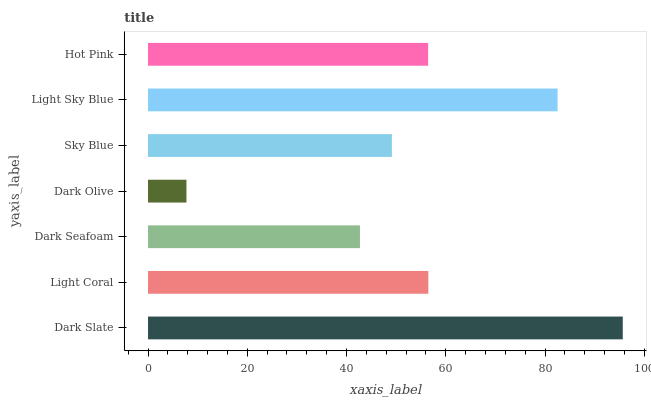Is Dark Olive the minimum?
Answer yes or no. Yes. Is Dark Slate the maximum?
Answer yes or no. Yes. Is Light Coral the minimum?
Answer yes or no. No. Is Light Coral the maximum?
Answer yes or no. No. Is Dark Slate greater than Light Coral?
Answer yes or no. Yes. Is Light Coral less than Dark Slate?
Answer yes or no. Yes. Is Light Coral greater than Dark Slate?
Answer yes or no. No. Is Dark Slate less than Light Coral?
Answer yes or no. No. Is Hot Pink the high median?
Answer yes or no. Yes. Is Hot Pink the low median?
Answer yes or no. Yes. Is Light Coral the high median?
Answer yes or no. No. Is Dark Slate the low median?
Answer yes or no. No. 